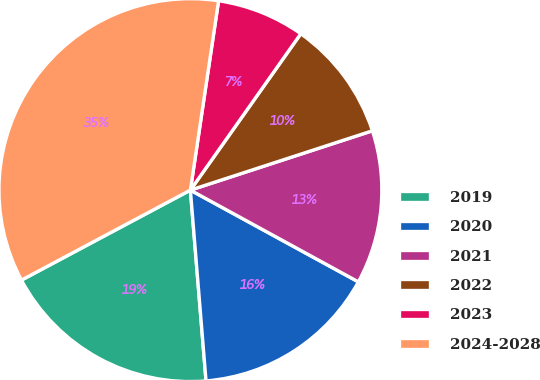<chart> <loc_0><loc_0><loc_500><loc_500><pie_chart><fcel>2019<fcel>2020<fcel>2021<fcel>2022<fcel>2023<fcel>2024-2028<nl><fcel>18.51%<fcel>15.74%<fcel>12.97%<fcel>10.2%<fcel>7.43%<fcel>35.14%<nl></chart> 